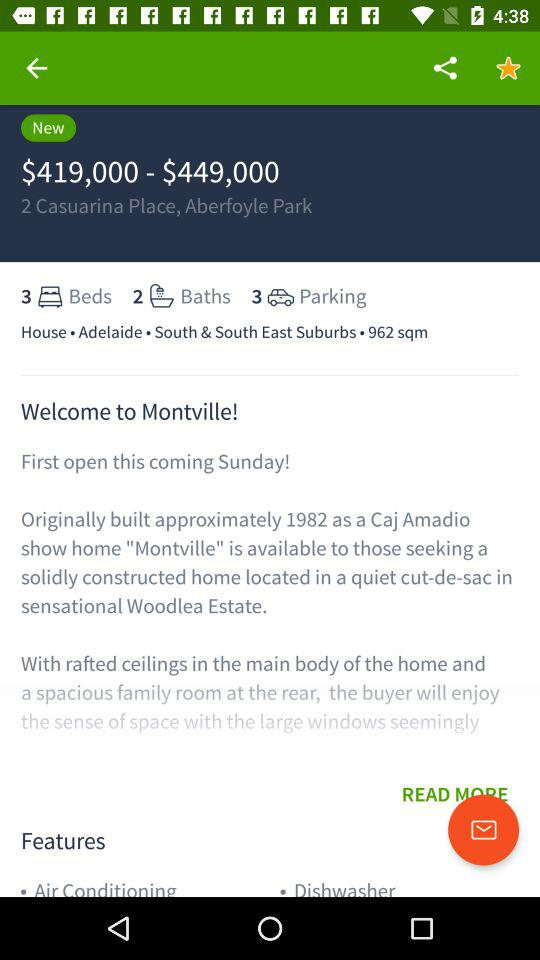What is the price range of the property?
Answer the question using a single word or phrase. $419,000 - $449,000 